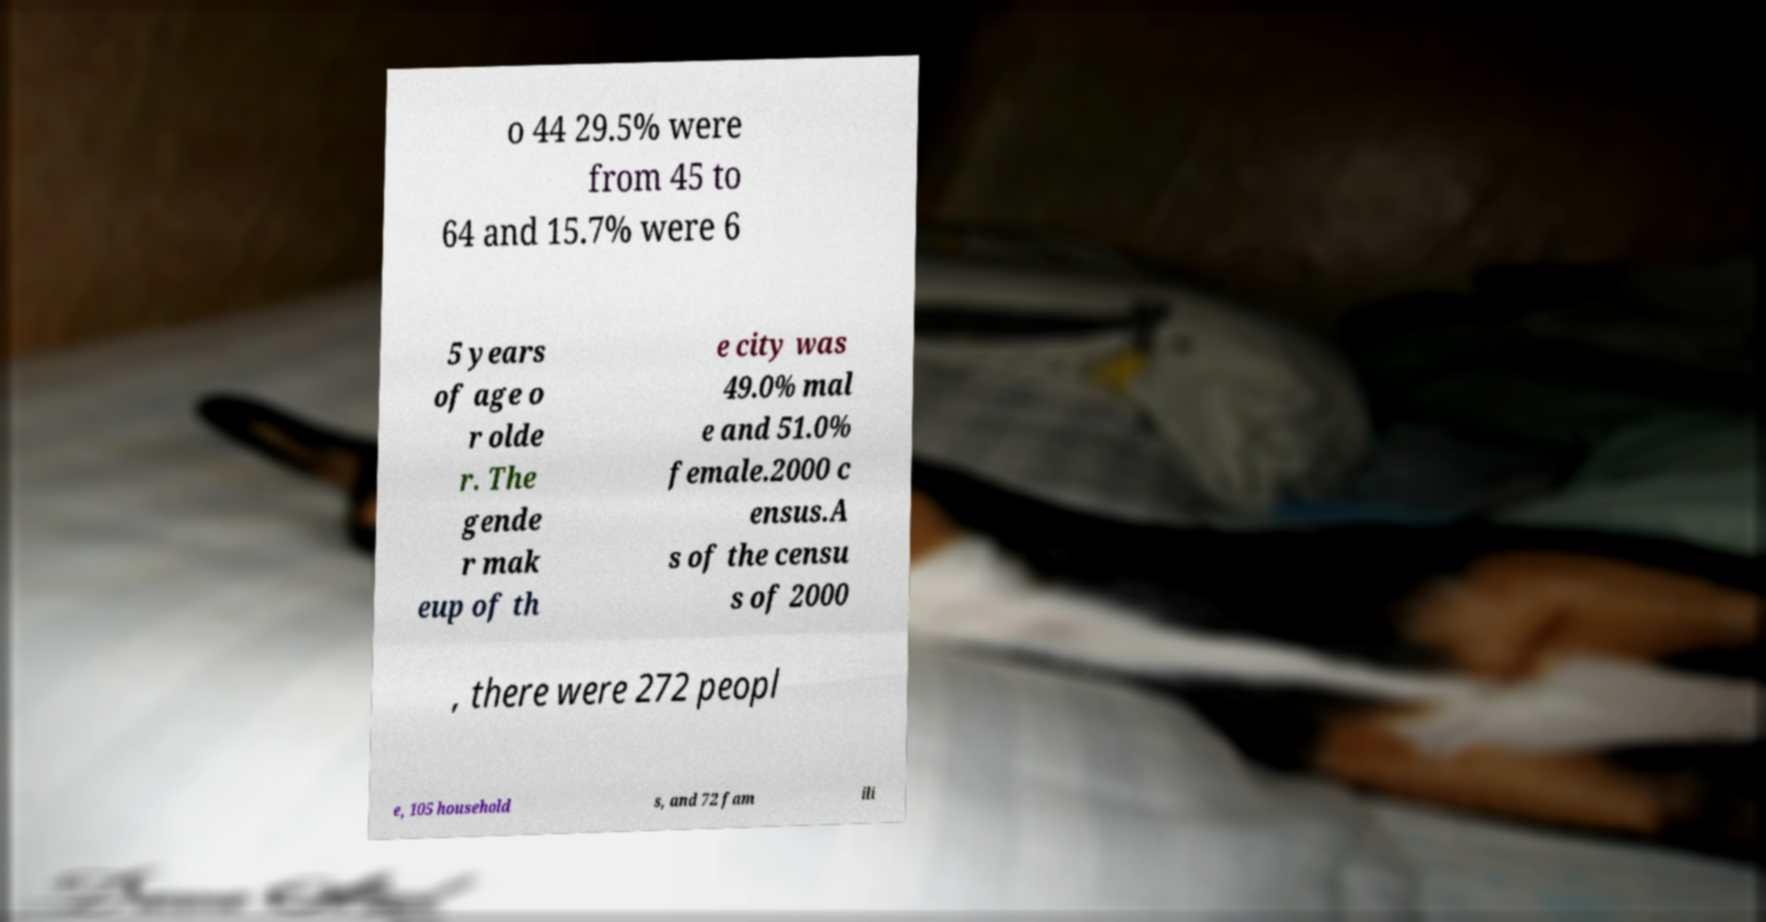Can you read and provide the text displayed in the image?This photo seems to have some interesting text. Can you extract and type it out for me? o 44 29.5% were from 45 to 64 and 15.7% were 6 5 years of age o r olde r. The gende r mak eup of th e city was 49.0% mal e and 51.0% female.2000 c ensus.A s of the censu s of 2000 , there were 272 peopl e, 105 household s, and 72 fam ili 